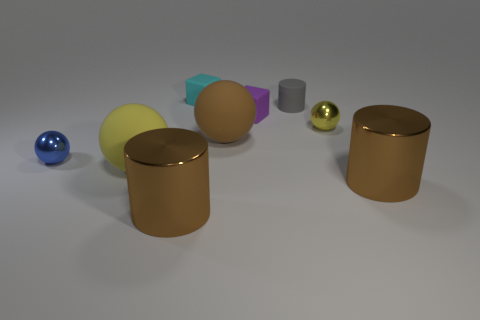How do the objects in this image relate to each other in terms of size? In this image, the sizes of the objects vary. Starting with the smallest, there's a silver sphere, then a golden sphere and a purple cuboid with similar scales. The yellow cylinder and the beige sphere are medium-sized. The blue sphere is slightly larger, and the copper cylinders are the largest objects present. 